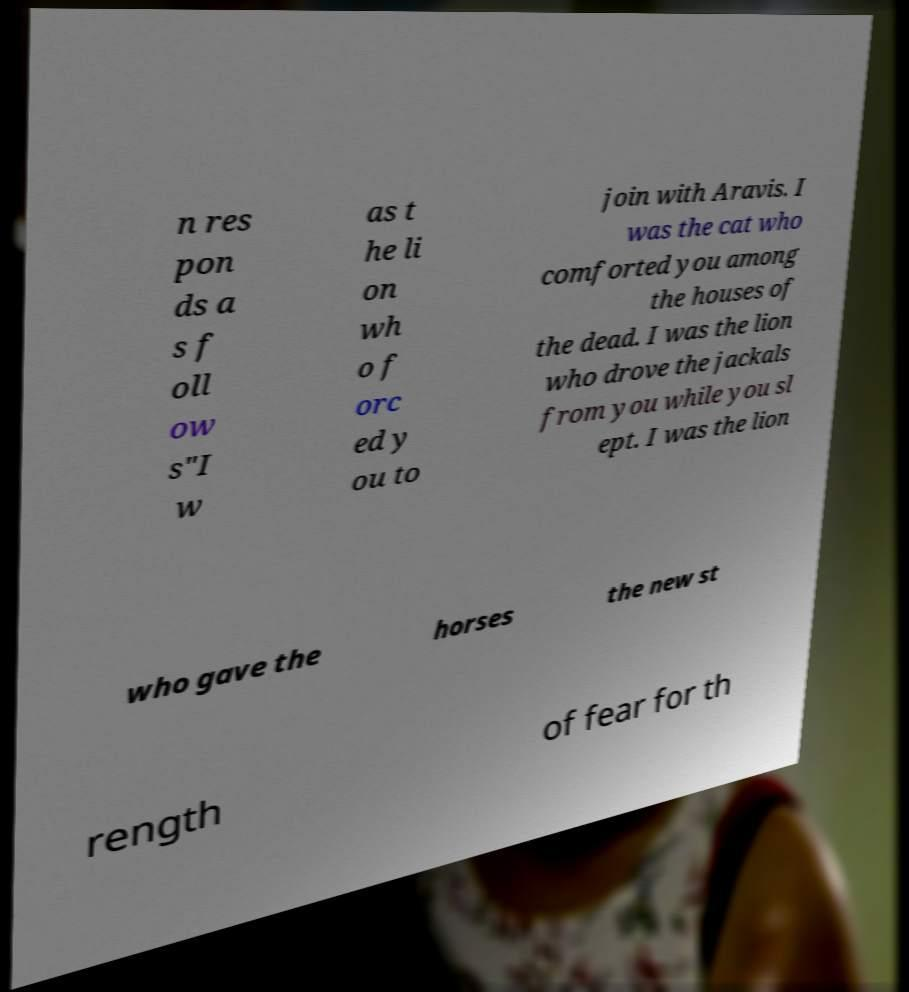Can you read and provide the text displayed in the image?This photo seems to have some interesting text. Can you extract and type it out for me? n res pon ds a s f oll ow s"I w as t he li on wh o f orc ed y ou to join with Aravis. I was the cat who comforted you among the houses of the dead. I was the lion who drove the jackals from you while you sl ept. I was the lion who gave the horses the new st rength of fear for th 